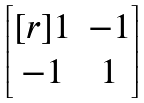Convert formula to latex. <formula><loc_0><loc_0><loc_500><loc_500>\begin{bmatrix} [ r ] 1 & - 1 \\ - 1 & 1 \end{bmatrix}</formula> 